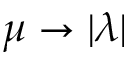Convert formula to latex. <formula><loc_0><loc_0><loc_500><loc_500>\mu \rightarrow | \lambda |</formula> 